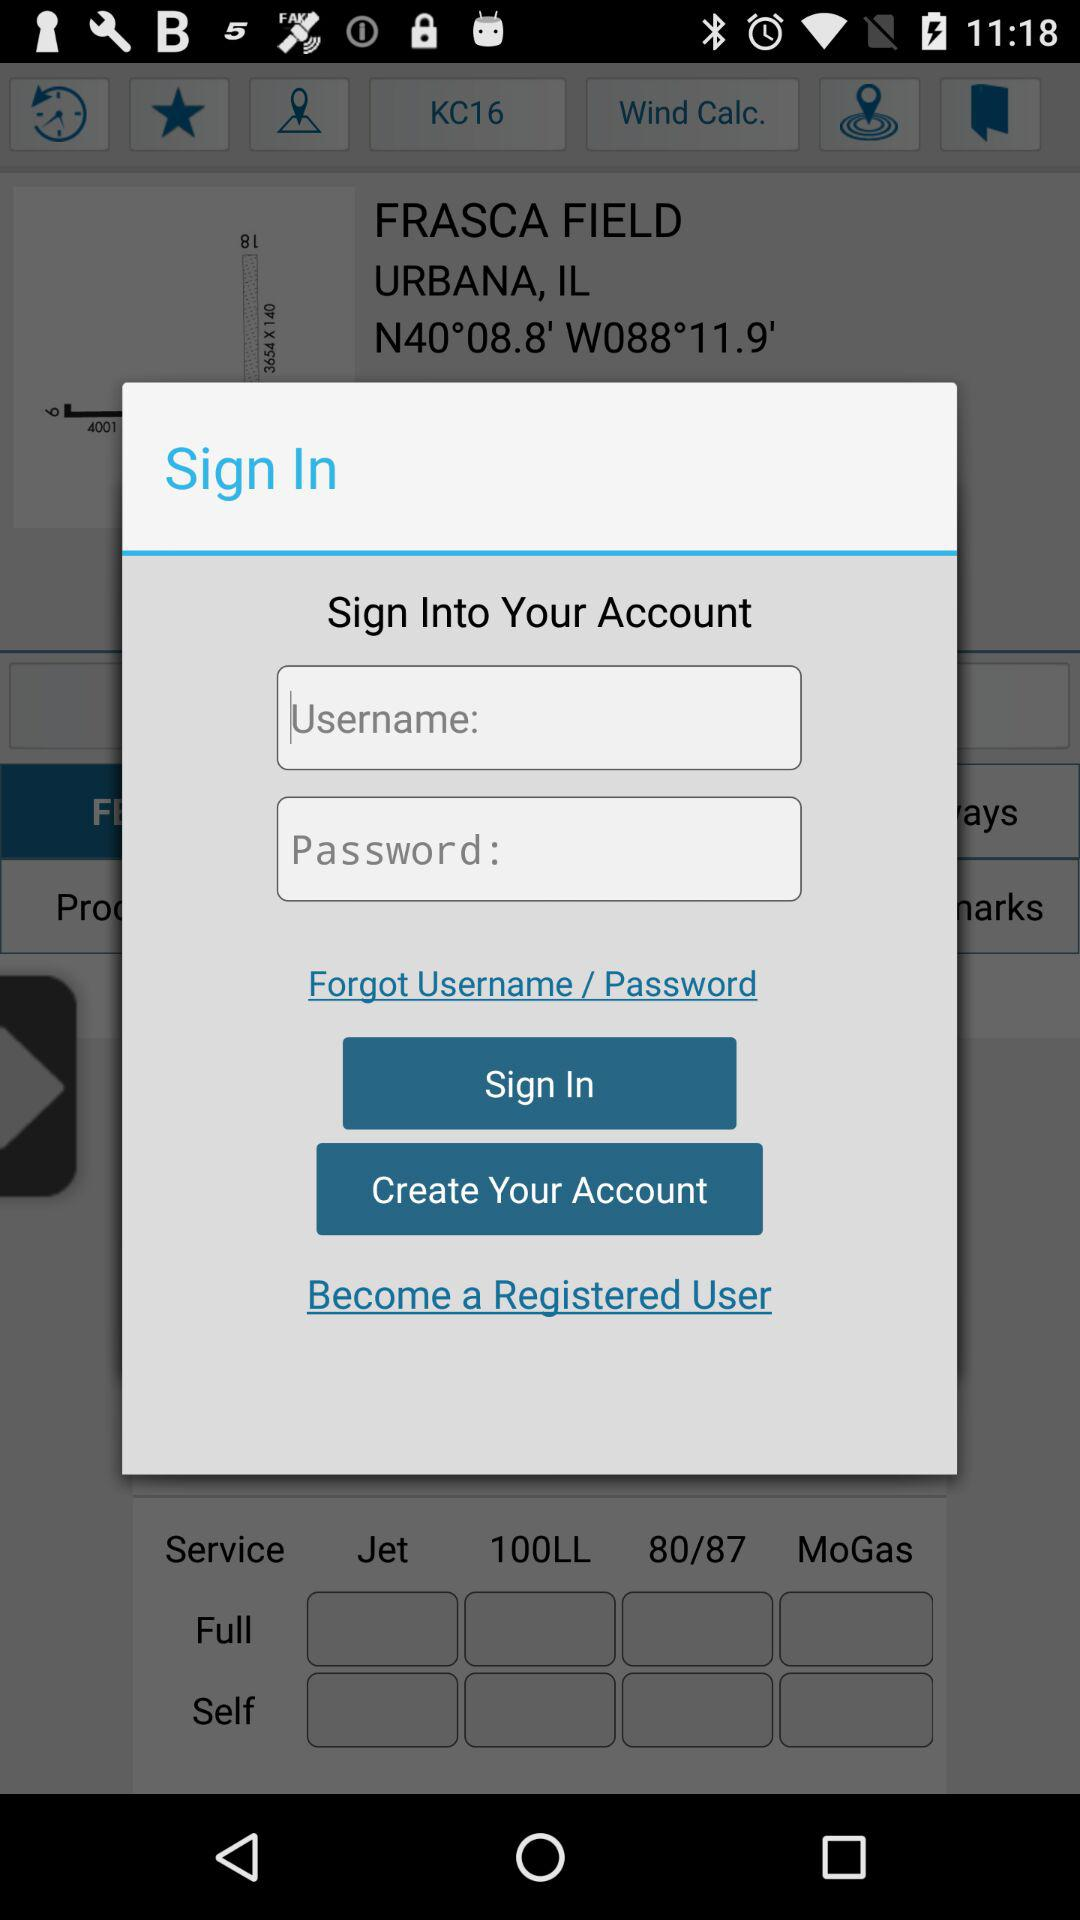What are the requirements to log in? The requirements to log in are "Username" and "Password". 